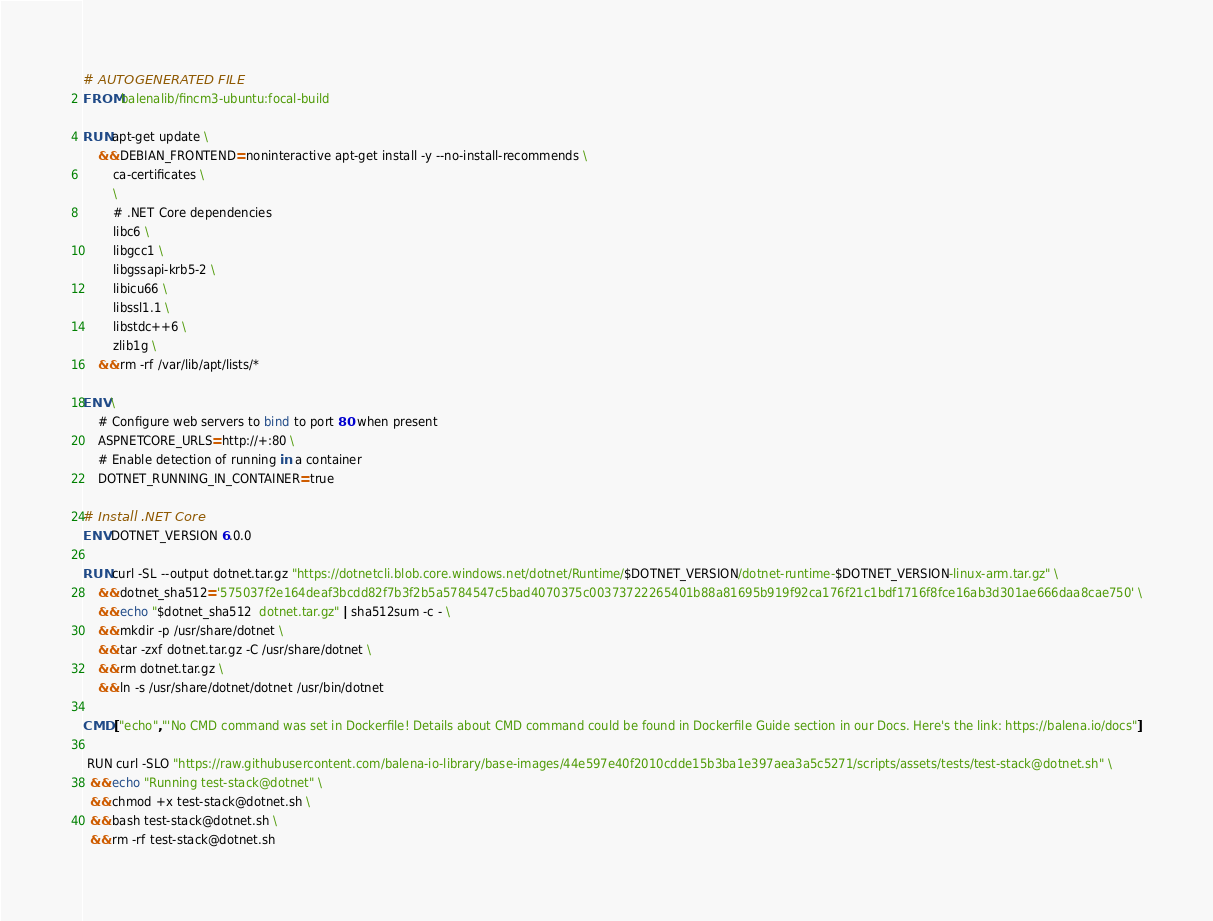Convert code to text. <code><loc_0><loc_0><loc_500><loc_500><_Dockerfile_># AUTOGENERATED FILE
FROM balenalib/fincm3-ubuntu:focal-build

RUN apt-get update \
    && DEBIAN_FRONTEND=noninteractive apt-get install -y --no-install-recommends \
        ca-certificates \
        \
        # .NET Core dependencies
        libc6 \
        libgcc1 \
        libgssapi-krb5-2 \
        libicu66 \
        libssl1.1 \
        libstdc++6 \
        zlib1g \
    && rm -rf /var/lib/apt/lists/*

ENV \
    # Configure web servers to bind to port 80 when present
    ASPNETCORE_URLS=http://+:80 \
    # Enable detection of running in a container
    DOTNET_RUNNING_IN_CONTAINER=true

# Install .NET Core
ENV DOTNET_VERSION 6.0.0

RUN curl -SL --output dotnet.tar.gz "https://dotnetcli.blob.core.windows.net/dotnet/Runtime/$DOTNET_VERSION/dotnet-runtime-$DOTNET_VERSION-linux-arm.tar.gz" \
    && dotnet_sha512='575037f2e164deaf3bcdd82f7b3f2b5a5784547c5bad4070375c00373722265401b88a81695b919f92ca176f21c1bdf1716f8fce16ab3d301ae666daa8cae750' \
    && echo "$dotnet_sha512  dotnet.tar.gz" | sha512sum -c - \
    && mkdir -p /usr/share/dotnet \
    && tar -zxf dotnet.tar.gz -C /usr/share/dotnet \
    && rm dotnet.tar.gz \
    && ln -s /usr/share/dotnet/dotnet /usr/bin/dotnet

CMD ["echo","'No CMD command was set in Dockerfile! Details about CMD command could be found in Dockerfile Guide section in our Docs. Here's the link: https://balena.io/docs"]

 RUN curl -SLO "https://raw.githubusercontent.com/balena-io-library/base-images/44e597e40f2010cdde15b3ba1e397aea3a5c5271/scripts/assets/tests/test-stack@dotnet.sh" \
  && echo "Running test-stack@dotnet" \
  && chmod +x test-stack@dotnet.sh \
  && bash test-stack@dotnet.sh \
  && rm -rf test-stack@dotnet.sh 
</code> 